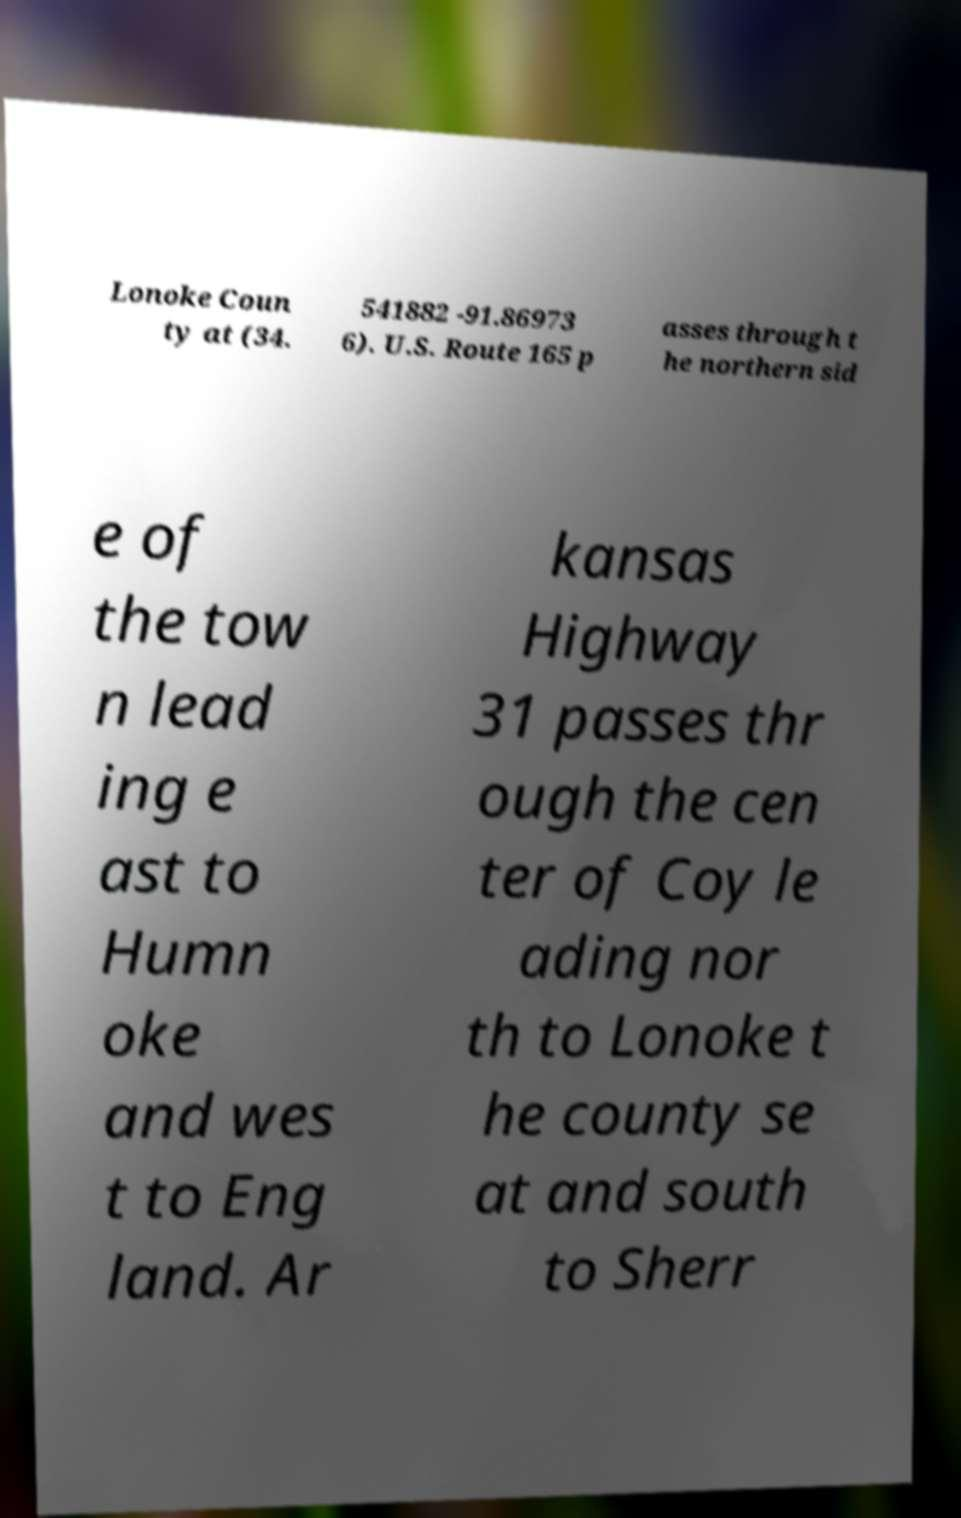There's text embedded in this image that I need extracted. Can you transcribe it verbatim? Lonoke Coun ty at (34. 541882 -91.86973 6). U.S. Route 165 p asses through t he northern sid e of the tow n lead ing e ast to Humn oke and wes t to Eng land. Ar kansas Highway 31 passes thr ough the cen ter of Coy le ading nor th to Lonoke t he county se at and south to Sherr 